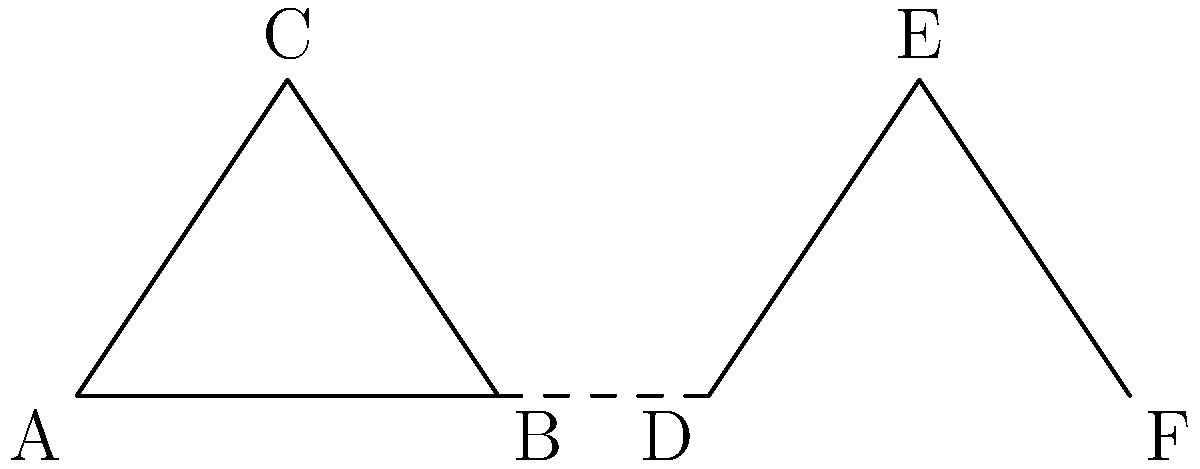In a trendy restaurant, a chef is experimenting with geometric food plating. She arranges appetizers in triangular shapes on rectangular plates. If triangle ABC is congruent to triangle DEF, and BD = 2 cm, what is the length of EF in centimeters? Let's approach this step-by-step:

1) First, we need to understand what congruent triangles mean. Congruent triangles have the same shape and size, which means all corresponding sides and angles are equal.

2) In this case, triangle ABC is congruent to triangle DEF. This means that AB = DE, BC = EF, and AC = DF.

3) We're given that BD = 2 cm. This line segment connects the two triangles.

4) Since the triangles are congruent, we know that AB = DE. We can see that AB + BD = DE.

5) Let's call the length of AB (and DE) x. Then we can write:
   $x + 2 = x$

6) This equation doesn't make sense unless x is infinite. However, we're dealing with real, finite food plates here.

7) The only way this arrangement works is if B and D are actually the same point. In other words, the two triangles are adjacent to each other.

8) If B and D are the same point, then EF is the same as BC.

9) Since the triangles are congruent, EF = BC = AB.

10) And since AB + BD = DE, and BD = 0 (because B and D are the same point), we can conclude that AB = DE = 4 cm.

Therefore, EF must also be 4 cm.
Answer: 4 cm 